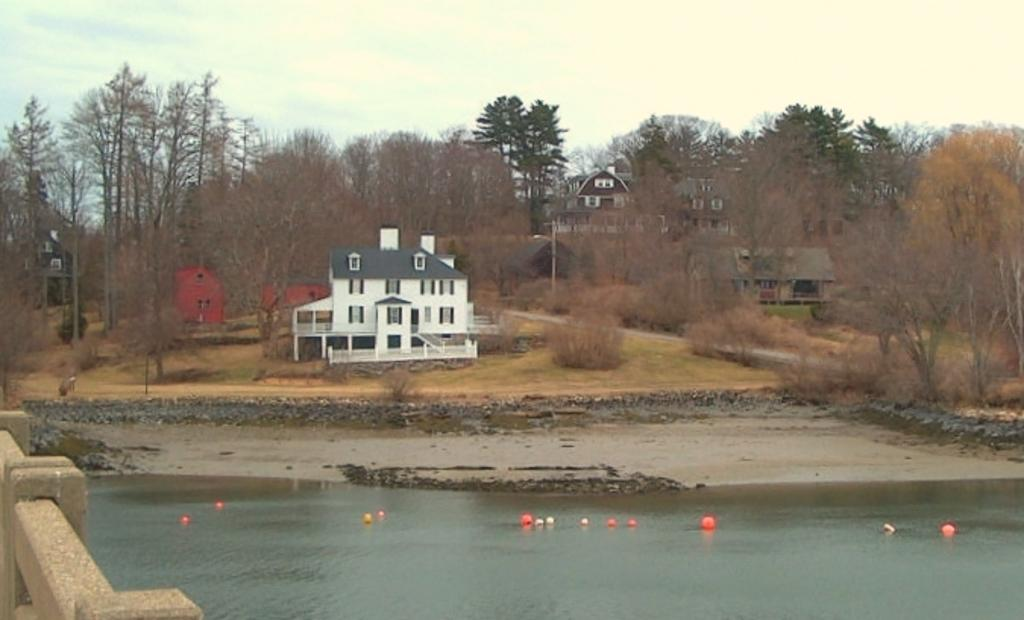What type of body of water is present in the image? There is a small lake in the image. What can be seen floating on the lake? There are balls on the lake. What type of vegetation is present in the image? There are trees in the image. What type of man-made structures are present in the image? There are buildings in the image. What is the temperature of the throat in the image? There is no reference to a throat in the image, so it is not possible to determine its temperature. 